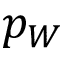<formula> <loc_0><loc_0><loc_500><loc_500>p _ { W }</formula> 